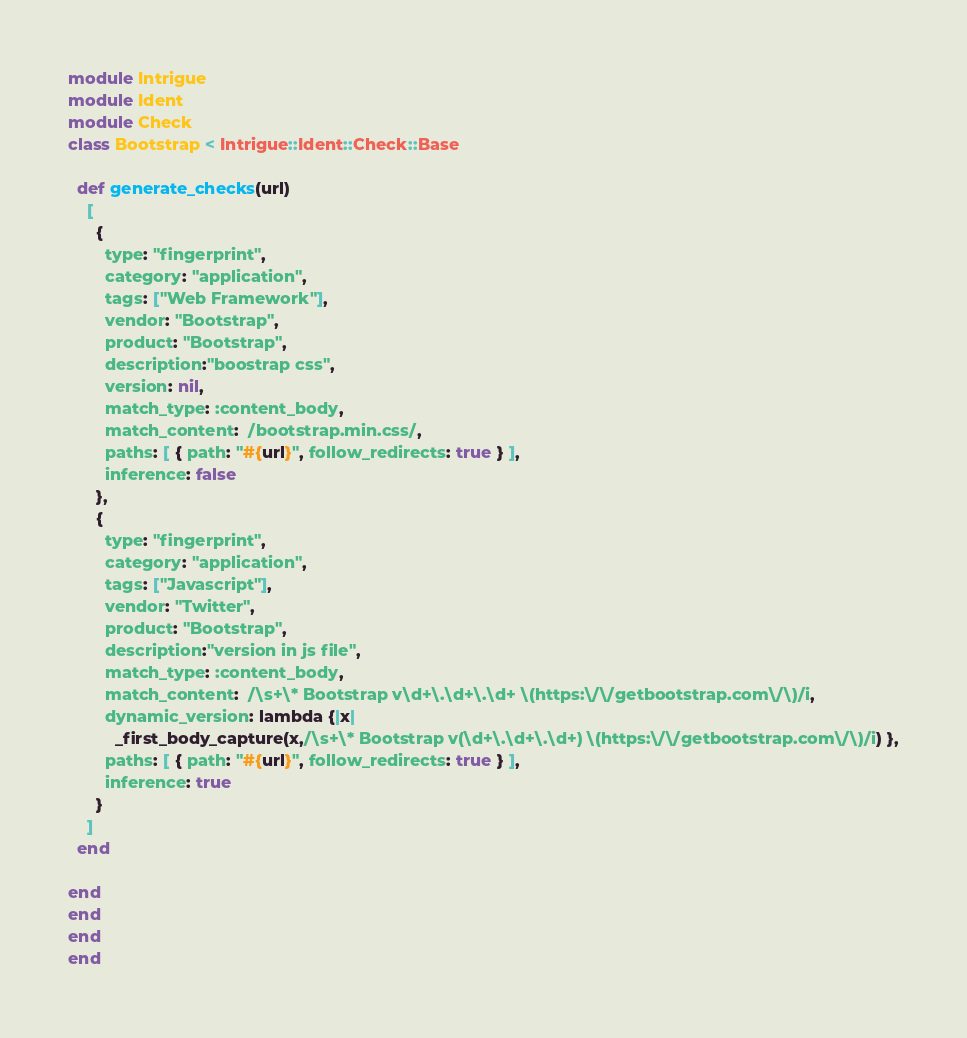Convert code to text. <code><loc_0><loc_0><loc_500><loc_500><_Ruby_>module Intrigue
module Ident
module Check
class Bootstrap < Intrigue::Ident::Check::Base

  def generate_checks(url)
    [
      {
        type: "fingerprint",
        category: "application",
        tags: ["Web Framework"],
        vendor: "Bootstrap",
        product: "Bootstrap",
        description:"boostrap css",
        version: nil,
        match_type: :content_body,
        match_content:  /bootstrap.min.css/,
        paths: [ { path: "#{url}", follow_redirects: true } ],
        inference: false
      },
      {
        type: "fingerprint",
        category: "application",
        tags: ["Javascript"],
        vendor: "Twitter",
        product: "Bootstrap",
        description:"version in js file",
        match_type: :content_body,
        match_content:  /\s+\* Bootstrap v\d+\.\d+\.\d+ \(https:\/\/getbootstrap.com\/\)/i,
        dynamic_version: lambda {|x| 
          _first_body_capture(x,/\s+\* Bootstrap v(\d+\.\d+\.\d+) \(https:\/\/getbootstrap.com\/\)/i) },
        paths: [ { path: "#{url}", follow_redirects: true } ],
        inference: true
      }
    ]
  end

end
end
end
end
</code> 